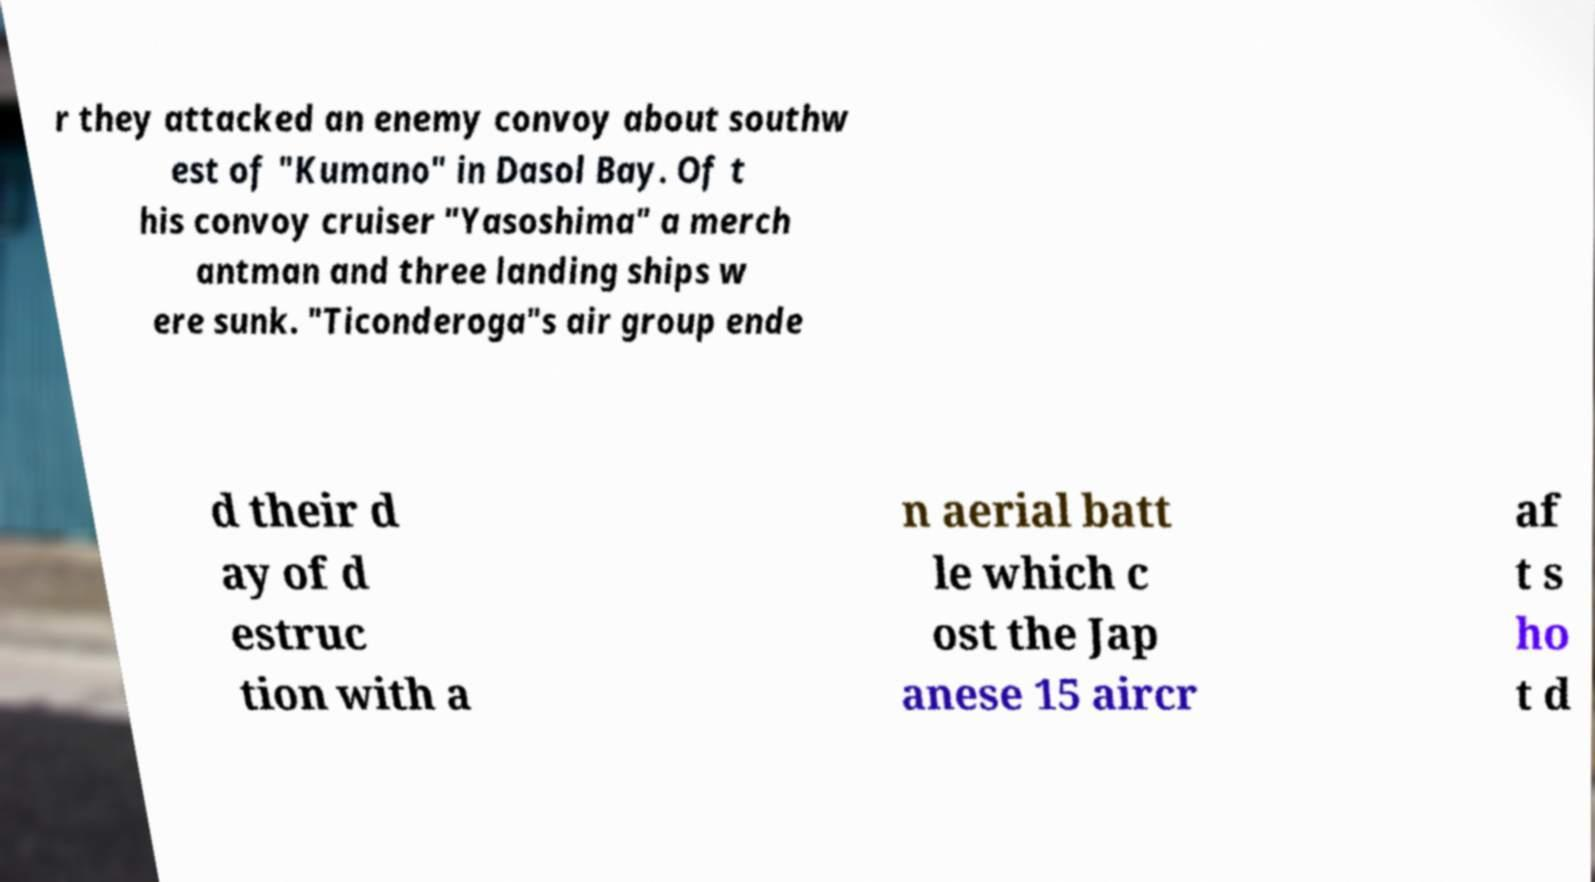Can you read and provide the text displayed in the image?This photo seems to have some interesting text. Can you extract and type it out for me? r they attacked an enemy convoy about southw est of "Kumano" in Dasol Bay. Of t his convoy cruiser "Yasoshima" a merch antman and three landing ships w ere sunk. "Ticonderoga"s air group ende d their d ay of d estruc tion with a n aerial batt le which c ost the Jap anese 15 aircr af t s ho t d 